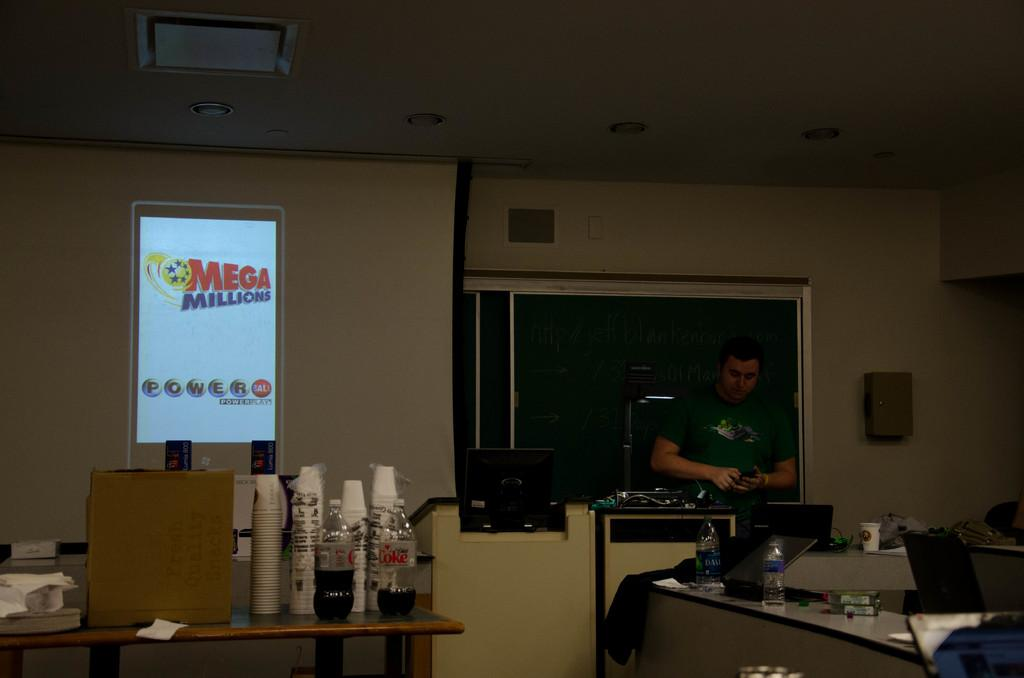Provide a one-sentence caption for the provided image. A man stand at a counter with a Mega Millions display next to him. 